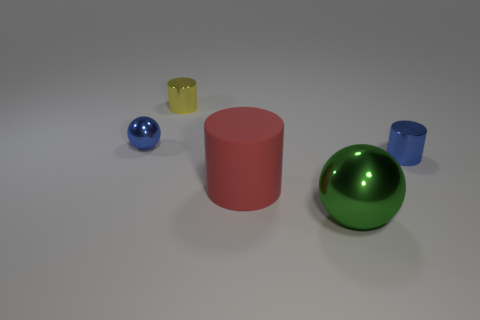Are the objects in the image arranged in a specific pattern or randomly placed? The objects in the image do not appear to follow a specific pattern; they are arranged in a manner that seems random but also balanced in composition. 